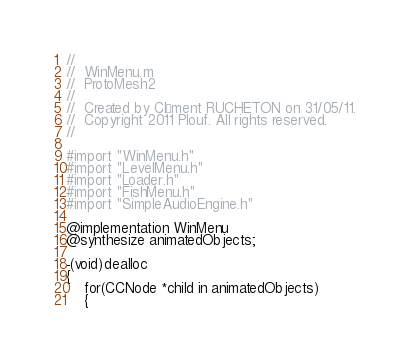<code> <loc_0><loc_0><loc_500><loc_500><_ObjectiveC_>//
//  WinMenu.m
//  ProtoMesh2
//
//  Created by Clément RUCHETON on 31/05/11.
//  Copyright 2011 Plouf. All rights reserved.
//

#import "WinMenu.h"
#import "LevelMenu.h"
#import "Loader.h"
#import "FishMenu.h"
#import "SimpleAudioEngine.h"

@implementation WinMenu
@synthesize animatedObjects;

-(void)dealloc
{
    for(CCNode *child in animatedObjects)
    {</code> 